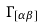Convert formula to latex. <formula><loc_0><loc_0><loc_500><loc_500>\Gamma _ { [ \alpha \beta ] }</formula> 